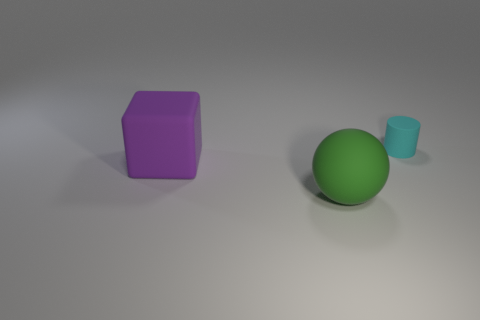Add 1 metallic cylinders. How many objects exist? 4 Subtract all cylinders. How many objects are left? 2 Add 3 cyan cylinders. How many cyan cylinders exist? 4 Subtract 0 yellow cylinders. How many objects are left? 3 Subtract all tiny green matte objects. Subtract all small rubber things. How many objects are left? 2 Add 1 matte balls. How many matte balls are left? 2 